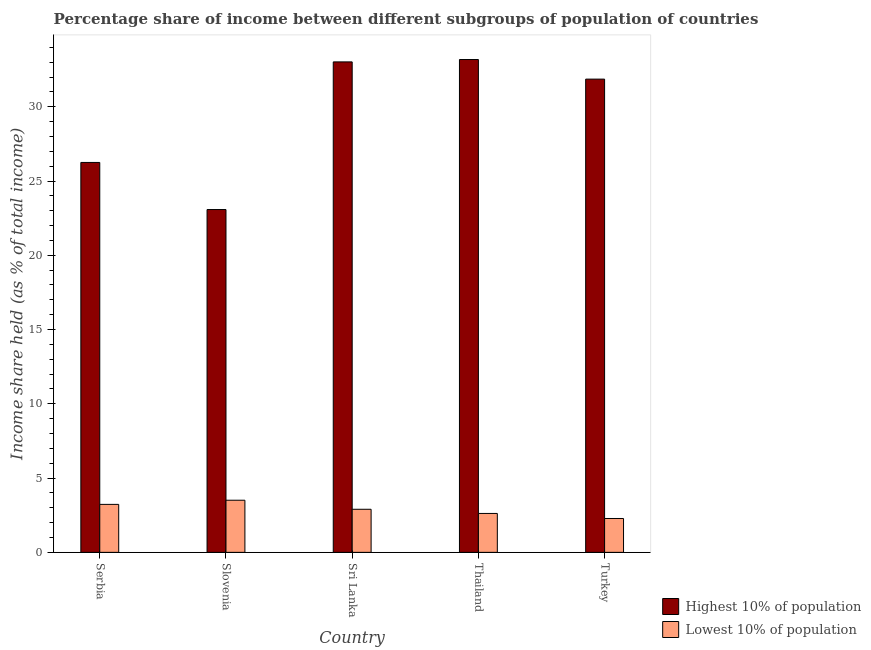Are the number of bars on each tick of the X-axis equal?
Make the answer very short. Yes. How many bars are there on the 4th tick from the left?
Your answer should be very brief. 2. How many bars are there on the 4th tick from the right?
Offer a very short reply. 2. What is the label of the 3rd group of bars from the left?
Provide a succinct answer. Sri Lanka. What is the income share held by lowest 10% of the population in Turkey?
Offer a terse response. 2.28. Across all countries, what is the maximum income share held by lowest 10% of the population?
Ensure brevity in your answer.  3.51. Across all countries, what is the minimum income share held by highest 10% of the population?
Offer a very short reply. 23.08. In which country was the income share held by highest 10% of the population maximum?
Provide a short and direct response. Thailand. In which country was the income share held by lowest 10% of the population minimum?
Give a very brief answer. Turkey. What is the total income share held by lowest 10% of the population in the graph?
Your answer should be compact. 14.54. What is the difference between the income share held by highest 10% of the population in Thailand and that in Turkey?
Offer a very short reply. 1.32. What is the difference between the income share held by lowest 10% of the population in Slovenia and the income share held by highest 10% of the population in Turkey?
Offer a very short reply. -28.35. What is the average income share held by lowest 10% of the population per country?
Provide a short and direct response. 2.91. What is the difference between the income share held by highest 10% of the population and income share held by lowest 10% of the population in Slovenia?
Provide a succinct answer. 19.57. In how many countries, is the income share held by highest 10% of the population greater than 28 %?
Offer a terse response. 3. What is the ratio of the income share held by lowest 10% of the population in Serbia to that in Thailand?
Offer a terse response. 1.23. What is the difference between the highest and the second highest income share held by lowest 10% of the population?
Provide a short and direct response. 0.28. What is the difference between the highest and the lowest income share held by highest 10% of the population?
Provide a succinct answer. 10.1. In how many countries, is the income share held by lowest 10% of the population greater than the average income share held by lowest 10% of the population taken over all countries?
Offer a terse response. 2. Is the sum of the income share held by lowest 10% of the population in Slovenia and Thailand greater than the maximum income share held by highest 10% of the population across all countries?
Give a very brief answer. No. What does the 2nd bar from the left in Serbia represents?
Offer a terse response. Lowest 10% of population. What does the 1st bar from the right in Thailand represents?
Provide a short and direct response. Lowest 10% of population. How many bars are there?
Make the answer very short. 10. Are all the bars in the graph horizontal?
Offer a terse response. No. What is the difference between two consecutive major ticks on the Y-axis?
Provide a short and direct response. 5. Are the values on the major ticks of Y-axis written in scientific E-notation?
Your answer should be very brief. No. Does the graph contain grids?
Your response must be concise. No. What is the title of the graph?
Offer a terse response. Percentage share of income between different subgroups of population of countries. Does "Net National savings" appear as one of the legend labels in the graph?
Ensure brevity in your answer.  No. What is the label or title of the Y-axis?
Your answer should be compact. Income share held (as % of total income). What is the Income share held (as % of total income) in Highest 10% of population in Serbia?
Offer a very short reply. 26.25. What is the Income share held (as % of total income) in Lowest 10% of population in Serbia?
Your answer should be compact. 3.23. What is the Income share held (as % of total income) in Highest 10% of population in Slovenia?
Provide a succinct answer. 23.08. What is the Income share held (as % of total income) in Lowest 10% of population in Slovenia?
Your response must be concise. 3.51. What is the Income share held (as % of total income) in Highest 10% of population in Sri Lanka?
Your response must be concise. 33.02. What is the Income share held (as % of total income) of Highest 10% of population in Thailand?
Your answer should be very brief. 33.18. What is the Income share held (as % of total income) of Lowest 10% of population in Thailand?
Your answer should be very brief. 2.62. What is the Income share held (as % of total income) of Highest 10% of population in Turkey?
Provide a succinct answer. 31.86. What is the Income share held (as % of total income) in Lowest 10% of population in Turkey?
Provide a short and direct response. 2.28. Across all countries, what is the maximum Income share held (as % of total income) in Highest 10% of population?
Your response must be concise. 33.18. Across all countries, what is the maximum Income share held (as % of total income) in Lowest 10% of population?
Keep it short and to the point. 3.51. Across all countries, what is the minimum Income share held (as % of total income) in Highest 10% of population?
Your answer should be very brief. 23.08. Across all countries, what is the minimum Income share held (as % of total income) in Lowest 10% of population?
Provide a short and direct response. 2.28. What is the total Income share held (as % of total income) in Highest 10% of population in the graph?
Ensure brevity in your answer.  147.39. What is the total Income share held (as % of total income) in Lowest 10% of population in the graph?
Offer a terse response. 14.54. What is the difference between the Income share held (as % of total income) of Highest 10% of population in Serbia and that in Slovenia?
Ensure brevity in your answer.  3.17. What is the difference between the Income share held (as % of total income) in Lowest 10% of population in Serbia and that in Slovenia?
Provide a short and direct response. -0.28. What is the difference between the Income share held (as % of total income) in Highest 10% of population in Serbia and that in Sri Lanka?
Provide a short and direct response. -6.77. What is the difference between the Income share held (as % of total income) of Lowest 10% of population in Serbia and that in Sri Lanka?
Provide a succinct answer. 0.33. What is the difference between the Income share held (as % of total income) in Highest 10% of population in Serbia and that in Thailand?
Offer a terse response. -6.93. What is the difference between the Income share held (as % of total income) of Lowest 10% of population in Serbia and that in Thailand?
Your answer should be very brief. 0.61. What is the difference between the Income share held (as % of total income) in Highest 10% of population in Serbia and that in Turkey?
Your response must be concise. -5.61. What is the difference between the Income share held (as % of total income) in Highest 10% of population in Slovenia and that in Sri Lanka?
Your answer should be compact. -9.94. What is the difference between the Income share held (as % of total income) in Lowest 10% of population in Slovenia and that in Sri Lanka?
Keep it short and to the point. 0.61. What is the difference between the Income share held (as % of total income) in Lowest 10% of population in Slovenia and that in Thailand?
Offer a very short reply. 0.89. What is the difference between the Income share held (as % of total income) in Highest 10% of population in Slovenia and that in Turkey?
Make the answer very short. -8.78. What is the difference between the Income share held (as % of total income) in Lowest 10% of population in Slovenia and that in Turkey?
Your answer should be compact. 1.23. What is the difference between the Income share held (as % of total income) in Highest 10% of population in Sri Lanka and that in Thailand?
Offer a very short reply. -0.16. What is the difference between the Income share held (as % of total income) in Lowest 10% of population in Sri Lanka and that in Thailand?
Keep it short and to the point. 0.28. What is the difference between the Income share held (as % of total income) in Highest 10% of population in Sri Lanka and that in Turkey?
Your answer should be compact. 1.16. What is the difference between the Income share held (as % of total income) in Lowest 10% of population in Sri Lanka and that in Turkey?
Ensure brevity in your answer.  0.62. What is the difference between the Income share held (as % of total income) in Highest 10% of population in Thailand and that in Turkey?
Make the answer very short. 1.32. What is the difference between the Income share held (as % of total income) of Lowest 10% of population in Thailand and that in Turkey?
Offer a terse response. 0.34. What is the difference between the Income share held (as % of total income) in Highest 10% of population in Serbia and the Income share held (as % of total income) in Lowest 10% of population in Slovenia?
Keep it short and to the point. 22.74. What is the difference between the Income share held (as % of total income) in Highest 10% of population in Serbia and the Income share held (as % of total income) in Lowest 10% of population in Sri Lanka?
Ensure brevity in your answer.  23.35. What is the difference between the Income share held (as % of total income) of Highest 10% of population in Serbia and the Income share held (as % of total income) of Lowest 10% of population in Thailand?
Your response must be concise. 23.63. What is the difference between the Income share held (as % of total income) in Highest 10% of population in Serbia and the Income share held (as % of total income) in Lowest 10% of population in Turkey?
Offer a very short reply. 23.97. What is the difference between the Income share held (as % of total income) in Highest 10% of population in Slovenia and the Income share held (as % of total income) in Lowest 10% of population in Sri Lanka?
Your answer should be compact. 20.18. What is the difference between the Income share held (as % of total income) in Highest 10% of population in Slovenia and the Income share held (as % of total income) in Lowest 10% of population in Thailand?
Give a very brief answer. 20.46. What is the difference between the Income share held (as % of total income) of Highest 10% of population in Slovenia and the Income share held (as % of total income) of Lowest 10% of population in Turkey?
Your response must be concise. 20.8. What is the difference between the Income share held (as % of total income) in Highest 10% of population in Sri Lanka and the Income share held (as % of total income) in Lowest 10% of population in Thailand?
Provide a short and direct response. 30.4. What is the difference between the Income share held (as % of total income) of Highest 10% of population in Sri Lanka and the Income share held (as % of total income) of Lowest 10% of population in Turkey?
Make the answer very short. 30.74. What is the difference between the Income share held (as % of total income) of Highest 10% of population in Thailand and the Income share held (as % of total income) of Lowest 10% of population in Turkey?
Your answer should be compact. 30.9. What is the average Income share held (as % of total income) of Highest 10% of population per country?
Keep it short and to the point. 29.48. What is the average Income share held (as % of total income) of Lowest 10% of population per country?
Your answer should be very brief. 2.91. What is the difference between the Income share held (as % of total income) in Highest 10% of population and Income share held (as % of total income) in Lowest 10% of population in Serbia?
Your answer should be compact. 23.02. What is the difference between the Income share held (as % of total income) of Highest 10% of population and Income share held (as % of total income) of Lowest 10% of population in Slovenia?
Keep it short and to the point. 19.57. What is the difference between the Income share held (as % of total income) of Highest 10% of population and Income share held (as % of total income) of Lowest 10% of population in Sri Lanka?
Your answer should be very brief. 30.12. What is the difference between the Income share held (as % of total income) in Highest 10% of population and Income share held (as % of total income) in Lowest 10% of population in Thailand?
Give a very brief answer. 30.56. What is the difference between the Income share held (as % of total income) of Highest 10% of population and Income share held (as % of total income) of Lowest 10% of population in Turkey?
Offer a terse response. 29.58. What is the ratio of the Income share held (as % of total income) in Highest 10% of population in Serbia to that in Slovenia?
Provide a succinct answer. 1.14. What is the ratio of the Income share held (as % of total income) in Lowest 10% of population in Serbia to that in Slovenia?
Your answer should be compact. 0.92. What is the ratio of the Income share held (as % of total income) in Highest 10% of population in Serbia to that in Sri Lanka?
Provide a succinct answer. 0.8. What is the ratio of the Income share held (as % of total income) of Lowest 10% of population in Serbia to that in Sri Lanka?
Offer a terse response. 1.11. What is the ratio of the Income share held (as % of total income) in Highest 10% of population in Serbia to that in Thailand?
Keep it short and to the point. 0.79. What is the ratio of the Income share held (as % of total income) of Lowest 10% of population in Serbia to that in Thailand?
Provide a succinct answer. 1.23. What is the ratio of the Income share held (as % of total income) of Highest 10% of population in Serbia to that in Turkey?
Your answer should be very brief. 0.82. What is the ratio of the Income share held (as % of total income) in Lowest 10% of population in Serbia to that in Turkey?
Your response must be concise. 1.42. What is the ratio of the Income share held (as % of total income) of Highest 10% of population in Slovenia to that in Sri Lanka?
Your answer should be compact. 0.7. What is the ratio of the Income share held (as % of total income) in Lowest 10% of population in Slovenia to that in Sri Lanka?
Provide a short and direct response. 1.21. What is the ratio of the Income share held (as % of total income) in Highest 10% of population in Slovenia to that in Thailand?
Ensure brevity in your answer.  0.7. What is the ratio of the Income share held (as % of total income) of Lowest 10% of population in Slovenia to that in Thailand?
Make the answer very short. 1.34. What is the ratio of the Income share held (as % of total income) in Highest 10% of population in Slovenia to that in Turkey?
Your answer should be compact. 0.72. What is the ratio of the Income share held (as % of total income) of Lowest 10% of population in Slovenia to that in Turkey?
Offer a terse response. 1.54. What is the ratio of the Income share held (as % of total income) in Lowest 10% of population in Sri Lanka to that in Thailand?
Keep it short and to the point. 1.11. What is the ratio of the Income share held (as % of total income) in Highest 10% of population in Sri Lanka to that in Turkey?
Provide a short and direct response. 1.04. What is the ratio of the Income share held (as % of total income) in Lowest 10% of population in Sri Lanka to that in Turkey?
Offer a terse response. 1.27. What is the ratio of the Income share held (as % of total income) in Highest 10% of population in Thailand to that in Turkey?
Provide a short and direct response. 1.04. What is the ratio of the Income share held (as % of total income) of Lowest 10% of population in Thailand to that in Turkey?
Your response must be concise. 1.15. What is the difference between the highest and the second highest Income share held (as % of total income) of Highest 10% of population?
Your response must be concise. 0.16. What is the difference between the highest and the second highest Income share held (as % of total income) of Lowest 10% of population?
Offer a very short reply. 0.28. What is the difference between the highest and the lowest Income share held (as % of total income) in Highest 10% of population?
Your response must be concise. 10.1. What is the difference between the highest and the lowest Income share held (as % of total income) of Lowest 10% of population?
Your response must be concise. 1.23. 